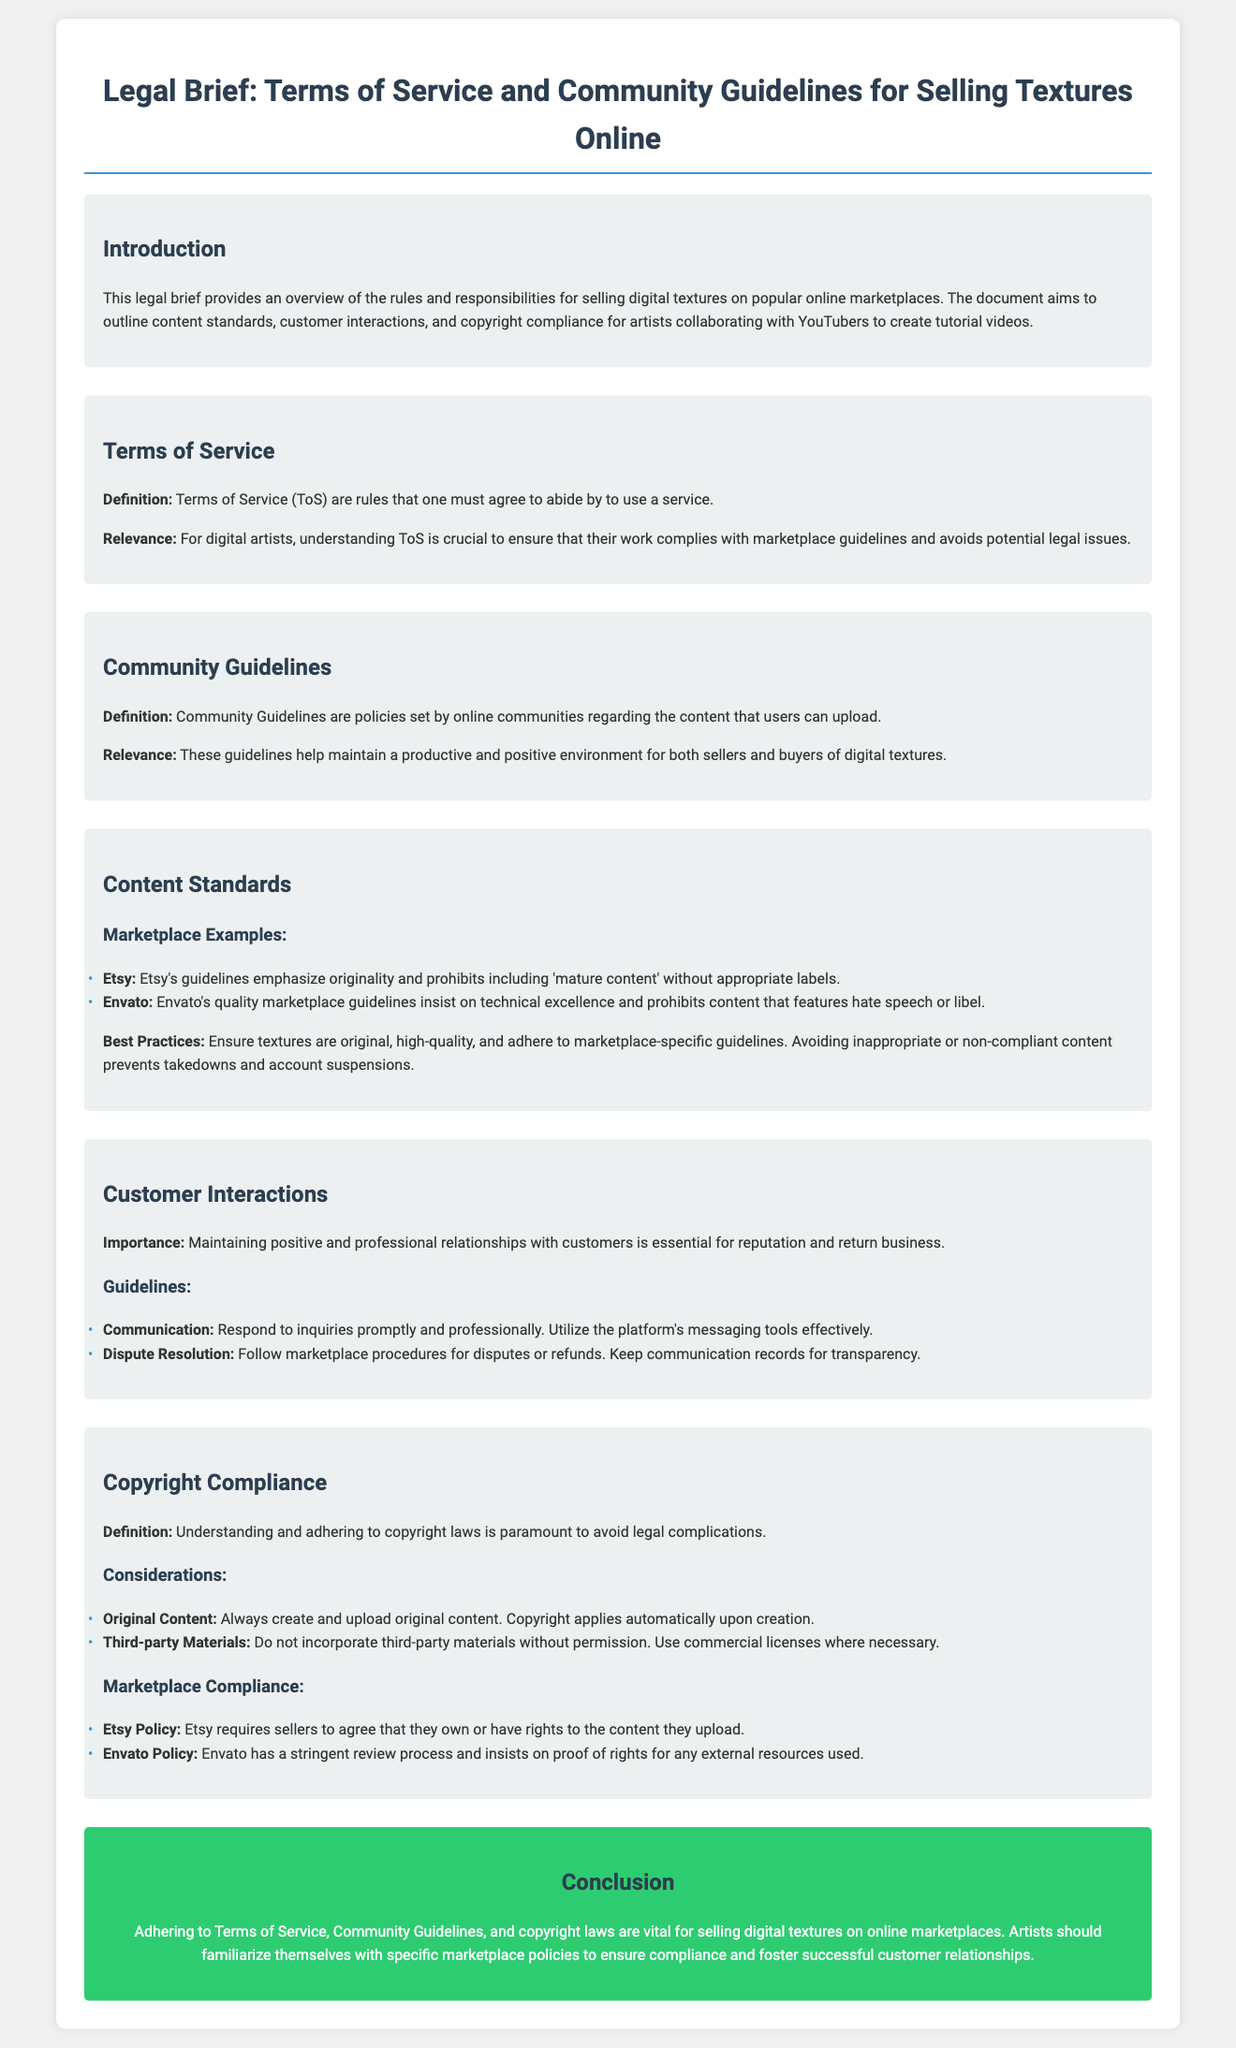What are the community guidelines? Community Guidelines are policies set by online communities regarding the content that users can upload.
Answer: Policies What is the emphasis of Etsy's guidelines? Etsy's guidelines emphasize originality and prohibits including 'mature content' without appropriate labels.
Answer: Originality What should artists ensure about their textures? Ensure textures are original, high-quality, and adhere to marketplace-specific guidelines.
Answer: Original and high-quality What is essential for maintaining customer relationships? Maintaining positive and professional relationships with customers is essential for reputation and return business.
Answer: Professional relationships What does copyright apply to? Copyright applies automatically upon creation.
Answer: Automatically upon creation What is Etsy's requirement for sellers regarding content? Etsy requires sellers to agree that they own or have rights to the content they upload.
Answer: Rights to content What should be done with third-party materials? Do not incorporate third-party materials without permission.
Answer: No incorporation without permission What is the primary reason for understanding Terms of Service? For digital artists, understanding ToS is crucial to ensure that their work complies with marketplace guidelines and avoids potential legal issues.
Answer: Compliance and legal issues 